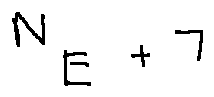<formula> <loc_0><loc_0><loc_500><loc_500>N _ { E } + 7</formula> 